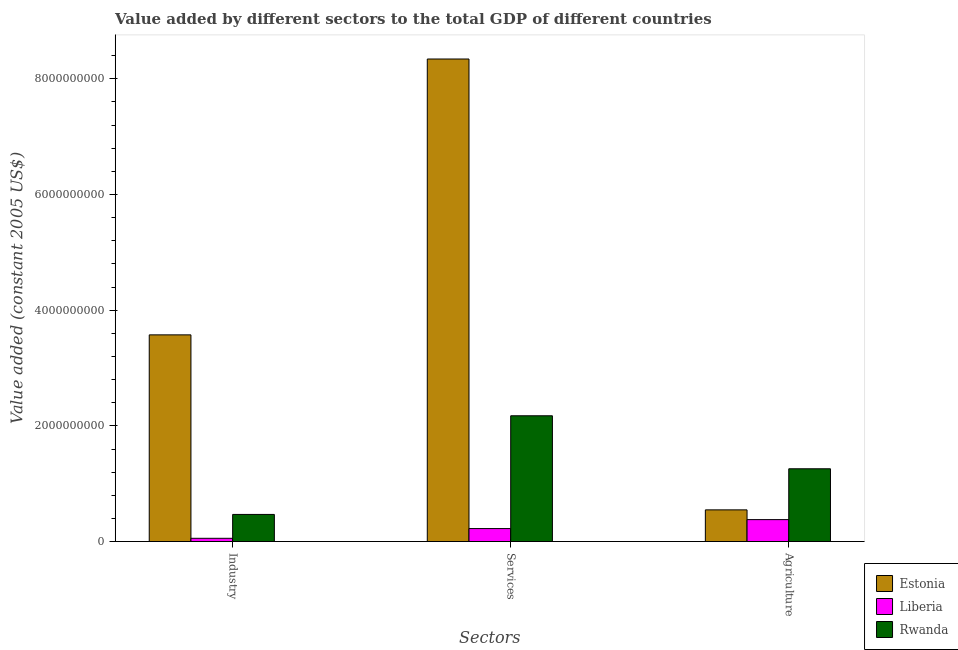How many different coloured bars are there?
Ensure brevity in your answer.  3. Are the number of bars per tick equal to the number of legend labels?
Give a very brief answer. Yes. Are the number of bars on each tick of the X-axis equal?
Offer a very short reply. Yes. How many bars are there on the 3rd tick from the left?
Give a very brief answer. 3. How many bars are there on the 3rd tick from the right?
Give a very brief answer. 3. What is the label of the 2nd group of bars from the left?
Give a very brief answer. Services. What is the value added by agricultural sector in Liberia?
Offer a terse response. 3.79e+08. Across all countries, what is the maximum value added by agricultural sector?
Provide a succinct answer. 1.26e+09. Across all countries, what is the minimum value added by agricultural sector?
Your answer should be compact. 3.79e+08. In which country was the value added by services maximum?
Your answer should be very brief. Estonia. In which country was the value added by services minimum?
Offer a very short reply. Liberia. What is the total value added by services in the graph?
Keep it short and to the point. 1.07e+1. What is the difference between the value added by services in Liberia and that in Rwanda?
Your answer should be very brief. -1.95e+09. What is the difference between the value added by services in Estonia and the value added by agricultural sector in Rwanda?
Offer a terse response. 7.08e+09. What is the average value added by agricultural sector per country?
Your answer should be very brief. 7.29e+08. What is the difference between the value added by agricultural sector and value added by services in Estonia?
Provide a succinct answer. -7.79e+09. What is the ratio of the value added by industrial sector in Estonia to that in Rwanda?
Give a very brief answer. 7.62. What is the difference between the highest and the second highest value added by agricultural sector?
Offer a very short reply. 7.10e+08. What is the difference between the highest and the lowest value added by industrial sector?
Give a very brief answer. 3.52e+09. What does the 1st bar from the left in Industry represents?
Provide a succinct answer. Estonia. What does the 2nd bar from the right in Agriculture represents?
Your answer should be compact. Liberia. Is it the case that in every country, the sum of the value added by industrial sector and value added by services is greater than the value added by agricultural sector?
Offer a terse response. No. Are all the bars in the graph horizontal?
Ensure brevity in your answer.  No. What is the difference between two consecutive major ticks on the Y-axis?
Keep it short and to the point. 2.00e+09. Does the graph contain any zero values?
Your answer should be very brief. No. How are the legend labels stacked?
Your answer should be very brief. Vertical. What is the title of the graph?
Make the answer very short. Value added by different sectors to the total GDP of different countries. What is the label or title of the X-axis?
Provide a succinct answer. Sectors. What is the label or title of the Y-axis?
Provide a short and direct response. Value added (constant 2005 US$). What is the Value added (constant 2005 US$) in Estonia in Industry?
Your response must be concise. 3.57e+09. What is the Value added (constant 2005 US$) in Liberia in Industry?
Provide a succinct answer. 5.63e+07. What is the Value added (constant 2005 US$) of Rwanda in Industry?
Your response must be concise. 4.69e+08. What is the Value added (constant 2005 US$) of Estonia in Services?
Offer a terse response. 8.34e+09. What is the Value added (constant 2005 US$) of Liberia in Services?
Provide a short and direct response. 2.25e+08. What is the Value added (constant 2005 US$) of Rwanda in Services?
Your response must be concise. 2.17e+09. What is the Value added (constant 2005 US$) of Estonia in Agriculture?
Ensure brevity in your answer.  5.48e+08. What is the Value added (constant 2005 US$) in Liberia in Agriculture?
Provide a short and direct response. 3.79e+08. What is the Value added (constant 2005 US$) of Rwanda in Agriculture?
Offer a terse response. 1.26e+09. Across all Sectors, what is the maximum Value added (constant 2005 US$) in Estonia?
Your answer should be compact. 8.34e+09. Across all Sectors, what is the maximum Value added (constant 2005 US$) of Liberia?
Your response must be concise. 3.79e+08. Across all Sectors, what is the maximum Value added (constant 2005 US$) in Rwanda?
Your answer should be very brief. 2.17e+09. Across all Sectors, what is the minimum Value added (constant 2005 US$) in Estonia?
Ensure brevity in your answer.  5.48e+08. Across all Sectors, what is the minimum Value added (constant 2005 US$) of Liberia?
Keep it short and to the point. 5.63e+07. Across all Sectors, what is the minimum Value added (constant 2005 US$) of Rwanda?
Your answer should be compact. 4.69e+08. What is the total Value added (constant 2005 US$) in Estonia in the graph?
Offer a very short reply. 1.25e+1. What is the total Value added (constant 2005 US$) in Liberia in the graph?
Offer a terse response. 6.60e+08. What is the total Value added (constant 2005 US$) in Rwanda in the graph?
Give a very brief answer. 3.90e+09. What is the difference between the Value added (constant 2005 US$) of Estonia in Industry and that in Services?
Your answer should be compact. -4.77e+09. What is the difference between the Value added (constant 2005 US$) of Liberia in Industry and that in Services?
Your answer should be compact. -1.68e+08. What is the difference between the Value added (constant 2005 US$) of Rwanda in Industry and that in Services?
Your response must be concise. -1.71e+09. What is the difference between the Value added (constant 2005 US$) in Estonia in Industry and that in Agriculture?
Give a very brief answer. 3.03e+09. What is the difference between the Value added (constant 2005 US$) of Liberia in Industry and that in Agriculture?
Give a very brief answer. -3.23e+08. What is the difference between the Value added (constant 2005 US$) in Rwanda in Industry and that in Agriculture?
Ensure brevity in your answer.  -7.89e+08. What is the difference between the Value added (constant 2005 US$) in Estonia in Services and that in Agriculture?
Offer a terse response. 7.79e+09. What is the difference between the Value added (constant 2005 US$) in Liberia in Services and that in Agriculture?
Ensure brevity in your answer.  -1.55e+08. What is the difference between the Value added (constant 2005 US$) of Rwanda in Services and that in Agriculture?
Your answer should be compact. 9.16e+08. What is the difference between the Value added (constant 2005 US$) of Estonia in Industry and the Value added (constant 2005 US$) of Liberia in Services?
Make the answer very short. 3.35e+09. What is the difference between the Value added (constant 2005 US$) in Estonia in Industry and the Value added (constant 2005 US$) in Rwanda in Services?
Your answer should be very brief. 1.40e+09. What is the difference between the Value added (constant 2005 US$) in Liberia in Industry and the Value added (constant 2005 US$) in Rwanda in Services?
Offer a terse response. -2.12e+09. What is the difference between the Value added (constant 2005 US$) of Estonia in Industry and the Value added (constant 2005 US$) of Liberia in Agriculture?
Provide a succinct answer. 3.19e+09. What is the difference between the Value added (constant 2005 US$) in Estonia in Industry and the Value added (constant 2005 US$) in Rwanda in Agriculture?
Keep it short and to the point. 2.32e+09. What is the difference between the Value added (constant 2005 US$) of Liberia in Industry and the Value added (constant 2005 US$) of Rwanda in Agriculture?
Provide a succinct answer. -1.20e+09. What is the difference between the Value added (constant 2005 US$) in Estonia in Services and the Value added (constant 2005 US$) in Liberia in Agriculture?
Your response must be concise. 7.96e+09. What is the difference between the Value added (constant 2005 US$) in Estonia in Services and the Value added (constant 2005 US$) in Rwanda in Agriculture?
Give a very brief answer. 7.08e+09. What is the difference between the Value added (constant 2005 US$) in Liberia in Services and the Value added (constant 2005 US$) in Rwanda in Agriculture?
Make the answer very short. -1.03e+09. What is the average Value added (constant 2005 US$) in Estonia per Sectors?
Keep it short and to the point. 4.15e+09. What is the average Value added (constant 2005 US$) of Liberia per Sectors?
Make the answer very short. 2.20e+08. What is the average Value added (constant 2005 US$) in Rwanda per Sectors?
Keep it short and to the point. 1.30e+09. What is the difference between the Value added (constant 2005 US$) in Estonia and Value added (constant 2005 US$) in Liberia in Industry?
Provide a succinct answer. 3.52e+09. What is the difference between the Value added (constant 2005 US$) of Estonia and Value added (constant 2005 US$) of Rwanda in Industry?
Your response must be concise. 3.10e+09. What is the difference between the Value added (constant 2005 US$) of Liberia and Value added (constant 2005 US$) of Rwanda in Industry?
Give a very brief answer. -4.13e+08. What is the difference between the Value added (constant 2005 US$) in Estonia and Value added (constant 2005 US$) in Liberia in Services?
Your answer should be compact. 8.12e+09. What is the difference between the Value added (constant 2005 US$) of Estonia and Value added (constant 2005 US$) of Rwanda in Services?
Ensure brevity in your answer.  6.17e+09. What is the difference between the Value added (constant 2005 US$) in Liberia and Value added (constant 2005 US$) in Rwanda in Services?
Offer a very short reply. -1.95e+09. What is the difference between the Value added (constant 2005 US$) in Estonia and Value added (constant 2005 US$) in Liberia in Agriculture?
Offer a terse response. 1.69e+08. What is the difference between the Value added (constant 2005 US$) in Estonia and Value added (constant 2005 US$) in Rwanda in Agriculture?
Ensure brevity in your answer.  -7.10e+08. What is the difference between the Value added (constant 2005 US$) in Liberia and Value added (constant 2005 US$) in Rwanda in Agriculture?
Your answer should be very brief. -8.79e+08. What is the ratio of the Value added (constant 2005 US$) of Estonia in Industry to that in Services?
Provide a short and direct response. 0.43. What is the ratio of the Value added (constant 2005 US$) in Liberia in Industry to that in Services?
Your answer should be very brief. 0.25. What is the ratio of the Value added (constant 2005 US$) of Rwanda in Industry to that in Services?
Provide a succinct answer. 0.22. What is the ratio of the Value added (constant 2005 US$) in Estonia in Industry to that in Agriculture?
Your response must be concise. 6.52. What is the ratio of the Value added (constant 2005 US$) of Liberia in Industry to that in Agriculture?
Ensure brevity in your answer.  0.15. What is the ratio of the Value added (constant 2005 US$) in Rwanda in Industry to that in Agriculture?
Ensure brevity in your answer.  0.37. What is the ratio of the Value added (constant 2005 US$) of Estonia in Services to that in Agriculture?
Your answer should be compact. 15.22. What is the ratio of the Value added (constant 2005 US$) in Liberia in Services to that in Agriculture?
Give a very brief answer. 0.59. What is the ratio of the Value added (constant 2005 US$) of Rwanda in Services to that in Agriculture?
Make the answer very short. 1.73. What is the difference between the highest and the second highest Value added (constant 2005 US$) of Estonia?
Keep it short and to the point. 4.77e+09. What is the difference between the highest and the second highest Value added (constant 2005 US$) of Liberia?
Provide a succinct answer. 1.55e+08. What is the difference between the highest and the second highest Value added (constant 2005 US$) in Rwanda?
Give a very brief answer. 9.16e+08. What is the difference between the highest and the lowest Value added (constant 2005 US$) of Estonia?
Offer a terse response. 7.79e+09. What is the difference between the highest and the lowest Value added (constant 2005 US$) in Liberia?
Your answer should be very brief. 3.23e+08. What is the difference between the highest and the lowest Value added (constant 2005 US$) in Rwanda?
Ensure brevity in your answer.  1.71e+09. 